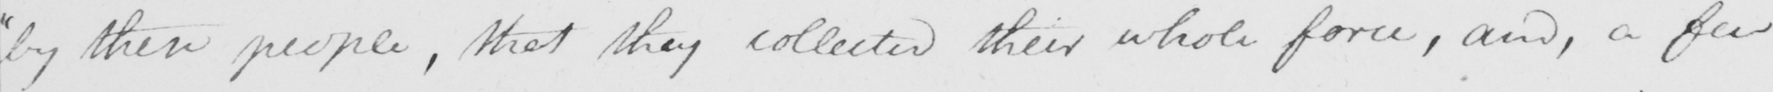Transcribe the text shown in this historical manuscript line. " by their people , that they collected their whole force , and , a few 